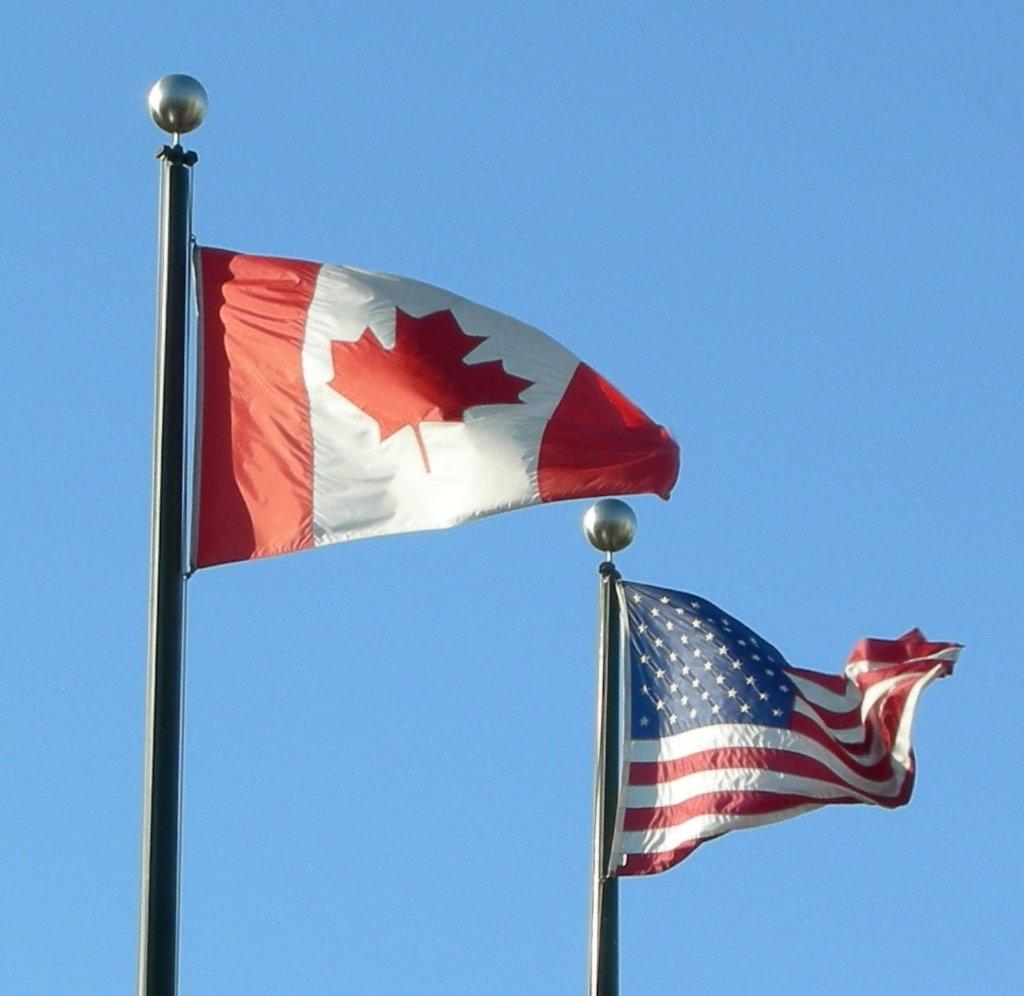How many flags can be seen in the image? There are two flags in the image. What are the flags doing in the image? The flags are flying in the air. How are the flags attached in the image? The flags are attached to a flag post. What is visible at the top of the image? The sky is visible at the top of the image. Can you see a cat walking on the feet of the flag post in the image? There is no cat or feet of a flag post present in the image. 